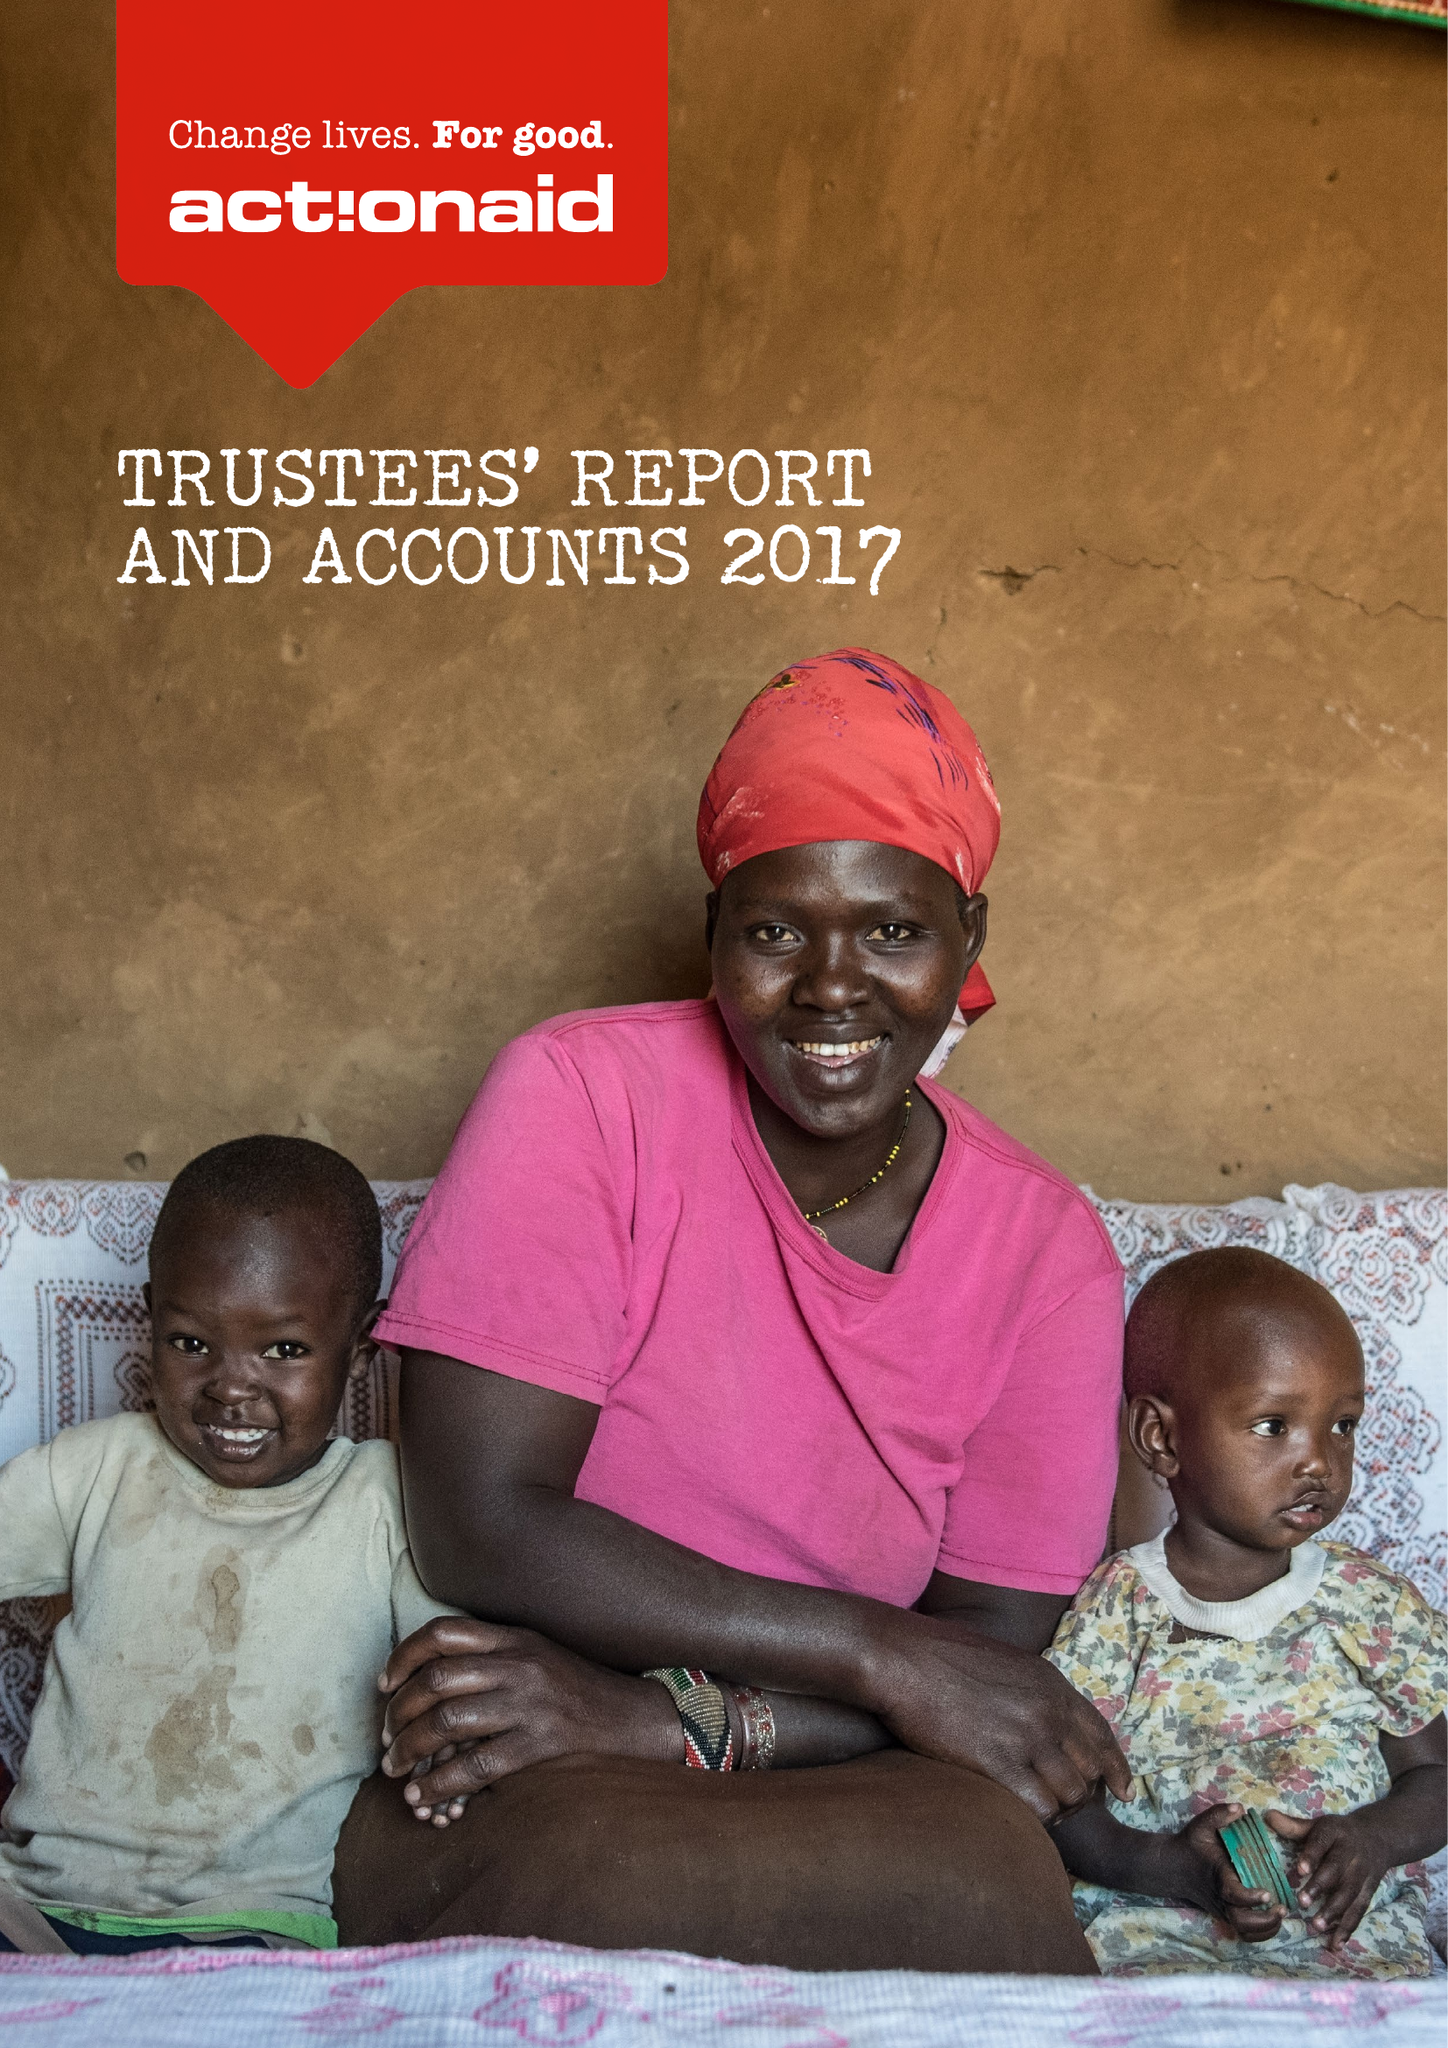What is the value for the address__post_town?
Answer the question using a single word or phrase. LONDON 